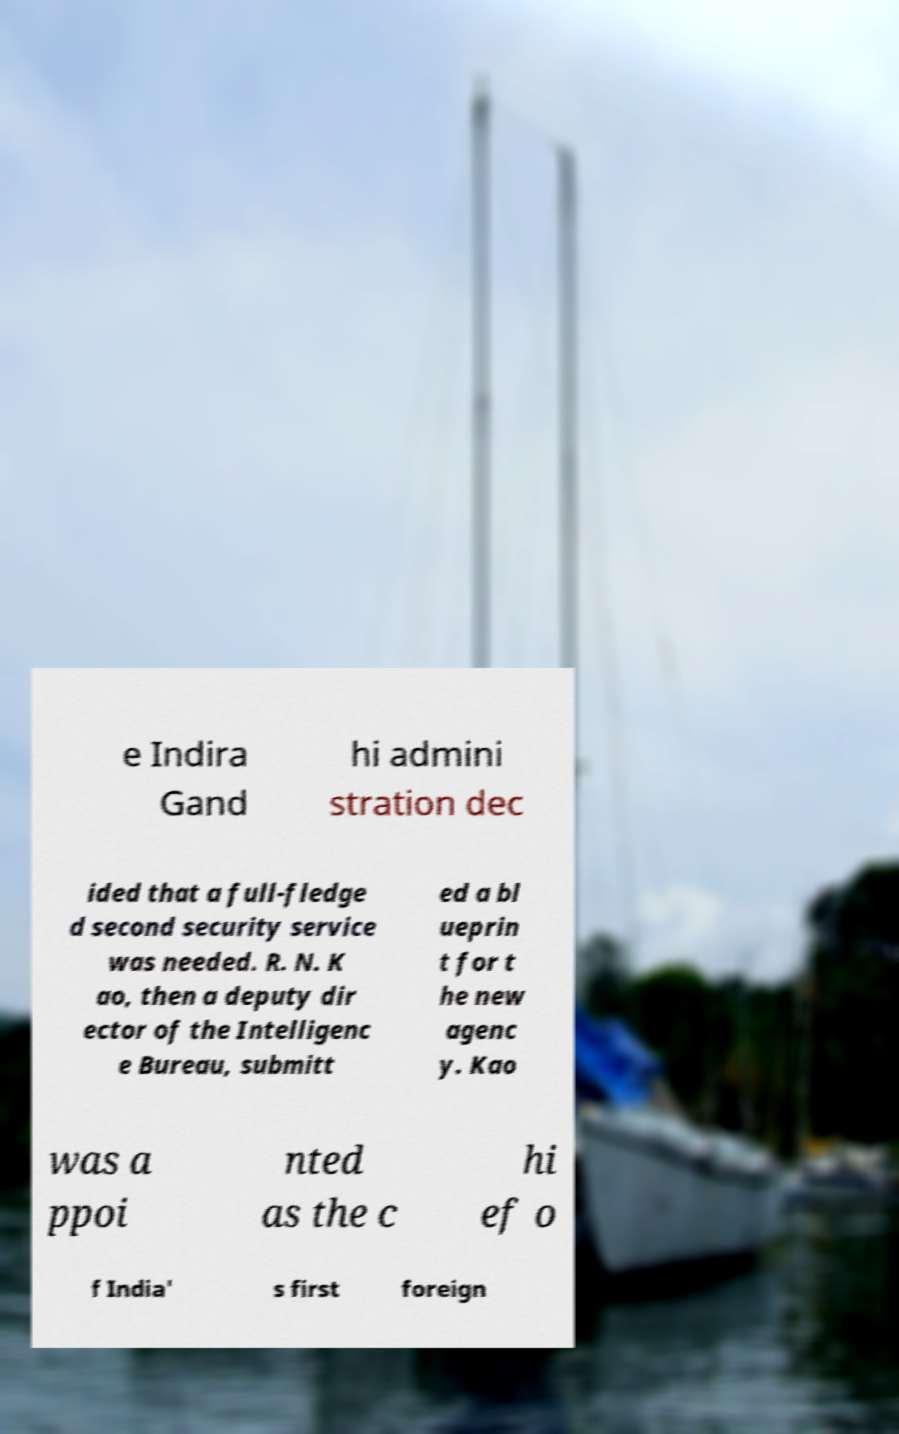What messages or text are displayed in this image? I need them in a readable, typed format. e Indira Gand hi admini stration dec ided that a full-fledge d second security service was needed. R. N. K ao, then a deputy dir ector of the Intelligenc e Bureau, submitt ed a bl ueprin t for t he new agenc y. Kao was a ppoi nted as the c hi ef o f India' s first foreign 